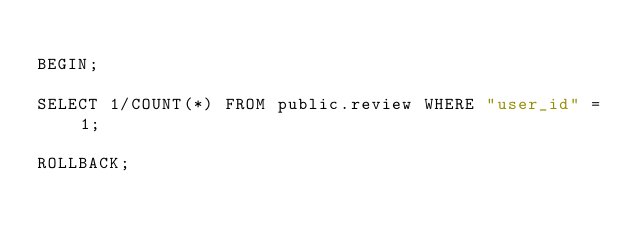<code> <loc_0><loc_0><loc_500><loc_500><_SQL_>
BEGIN;

SELECT 1/COUNT(*) FROM public.review WHERE "user_id" = 1;

ROLLBACK;
</code> 